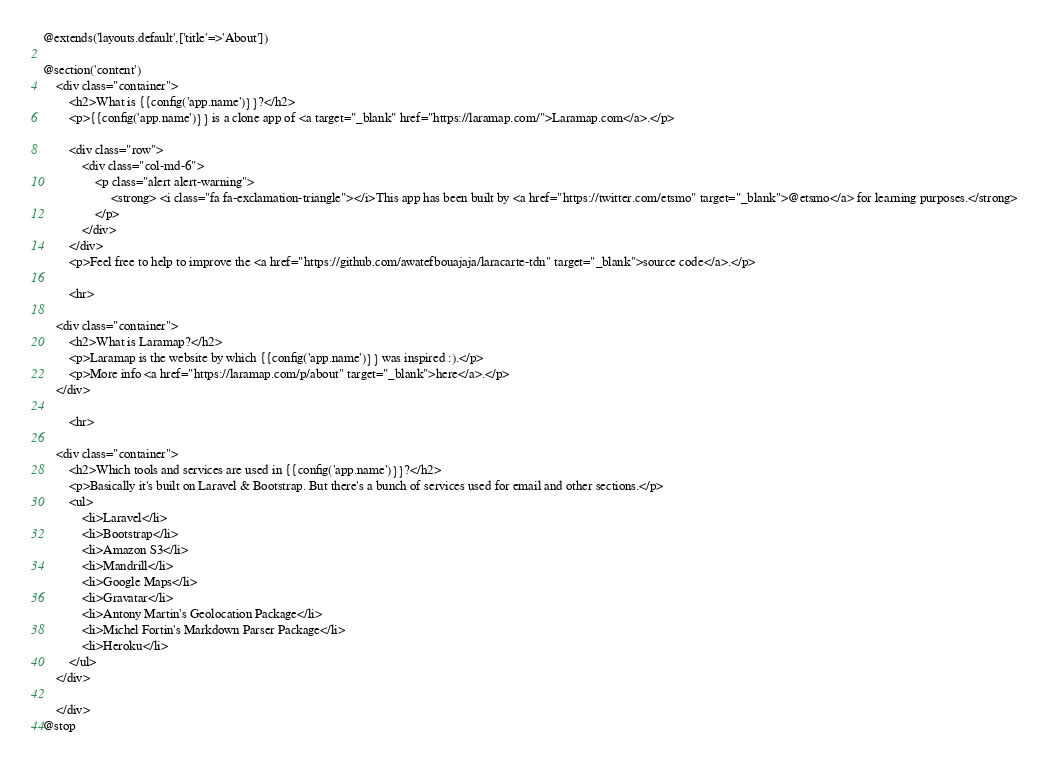Convert code to text. <code><loc_0><loc_0><loc_500><loc_500><_PHP_>@extends('layouts.default',['title'=>'About'])

@section('content')
	<div class="container">
		<h2>What is {{config('app.name')}}?</h2>
		<p>{{config('app.name')}} is a clone app of <a target="_blank" href="https://laramap.com/">Laramap.com</a>.</p>

		<div class="row">
			<div class="col-md-6">
				<p class="alert alert-warning">
					 <strong> <i class="fa fa-exclamation-triangle"></i>This app has been built by <a href="https://twitter.com/etsmo" target="_blank">@etsmo</a> for learning purposes.</strong>
				</p>
			</div>
		</div>
		<p>Feel free to help to improve the <a href="https://github.com/awatefbouajaja/laracarte-tdn" target="_blank">source code</a>.</p>

		<hr>

	<div class="container">
		<h2>What is Laramap?</h2>
		<p>Laramap is the website by which {{config('app.name')}} was inspired :).</p>
		<p>More info <a href="https://laramap.com/p/about" target="_blank">here</a>.</p>
	</div>

		<hr>

	<div class="container">
		<h2>Which tools and services are used in {{config('app.name')}}?</h2>
		<p>Basically it's built on Laravel & Bootstrap. But there's a bunch of services used for email and other sections.</p>
		<ul>
			<li>Laravel</li>
			<li>Bootstrap</li>
			<li>Amazon S3</li>
			<li>Mandrill</li>
			<li>Google Maps</li>
			<li>Gravatar</li>
			<li>Antony Martin's Geolocation Package</li>
			<li>Michel Fortin's Markdown Parser Package</li>
			<li>Heroku</li>
		</ul>
	</div>

	</div>
@stop</code> 